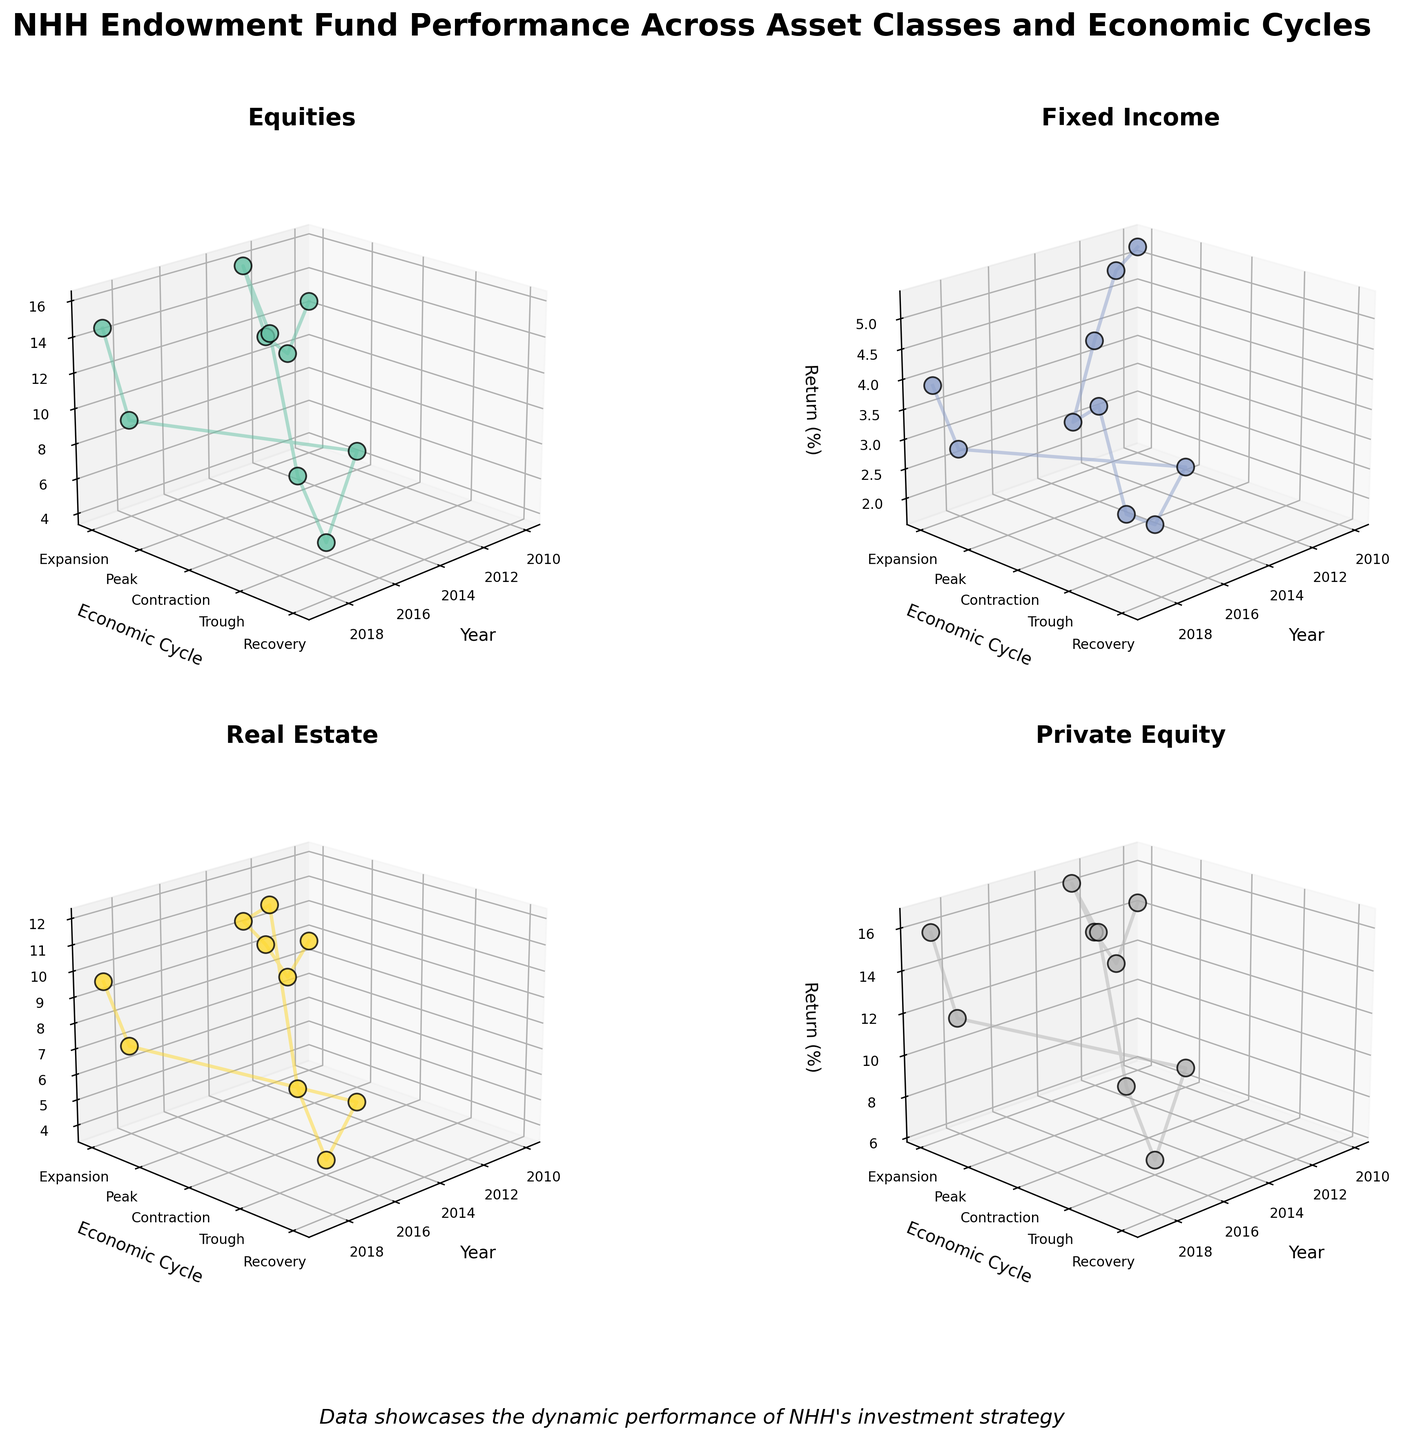What are the years represented in the plots? The x-axis of the subplots shows the years, you can identify the range of years by looking at the plots.
Answer: 2010-2019 Which asset class has the highest return in 2013? Look at the z-axis values for the year 2013 across all four subplots, the asset class with the highest peak value represents the highest return.
Answer: Equities During which economic cycle did Fixed Income have the lowest return? Observe the y-axis (economic cycle) associated with the lowest z-axis (return) value in the Fixed Income subplot.
Answer: Contraction What's the general trend for Real Estate returns during expansion periods? Examine the Real Estate subplot and observe the z-axis values for the Economic Cycle set to '0' (Expansion) over the years.
Answer: Generally increasing Compare the peak return of Private Equity during the 'Peak' and 'Trough' cycles. Which is higher? Look at the z-axis values for the y-axis (Economic Cycle) labeled '1' (Peak) and '3' (Trough) in the Private Equity subplot and compare the two.
Answer: Peak Which economic cycle has the most consistent returns for Equities? Observe the Equities subplot and compare the consistency of z-axis values for each economic cycle (y-axis values).
Answer: Expansion What is the average return of Fixed Income during expansion periods? Identify the z-axis values corresponding to the expansion periods (y=0) in the Fixed Income subplot, sum these values, and divide by the number of observations. (5.2 + 4.9 + 3.8 + 2.5 + 2.7 + 3.9) / 6 = 3.83
Answer: 3.83 Which asset class shows the greatest variability in returns? Compare the range (max - min) of z-axis values across all subplots.
Answer: Private Equity 